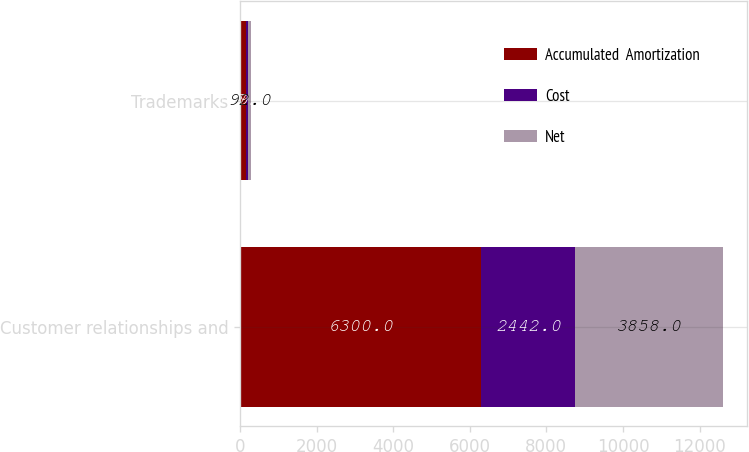Convert chart. <chart><loc_0><loc_0><loc_500><loc_500><stacked_bar_chart><ecel><fcel>Customer relationships and<fcel>Trademarks<nl><fcel>Accumulated  Amortization<fcel>6300<fcel>149<nl><fcel>Cost<fcel>2442<fcel>57<nl><fcel>Net<fcel>3858<fcel>92<nl></chart> 